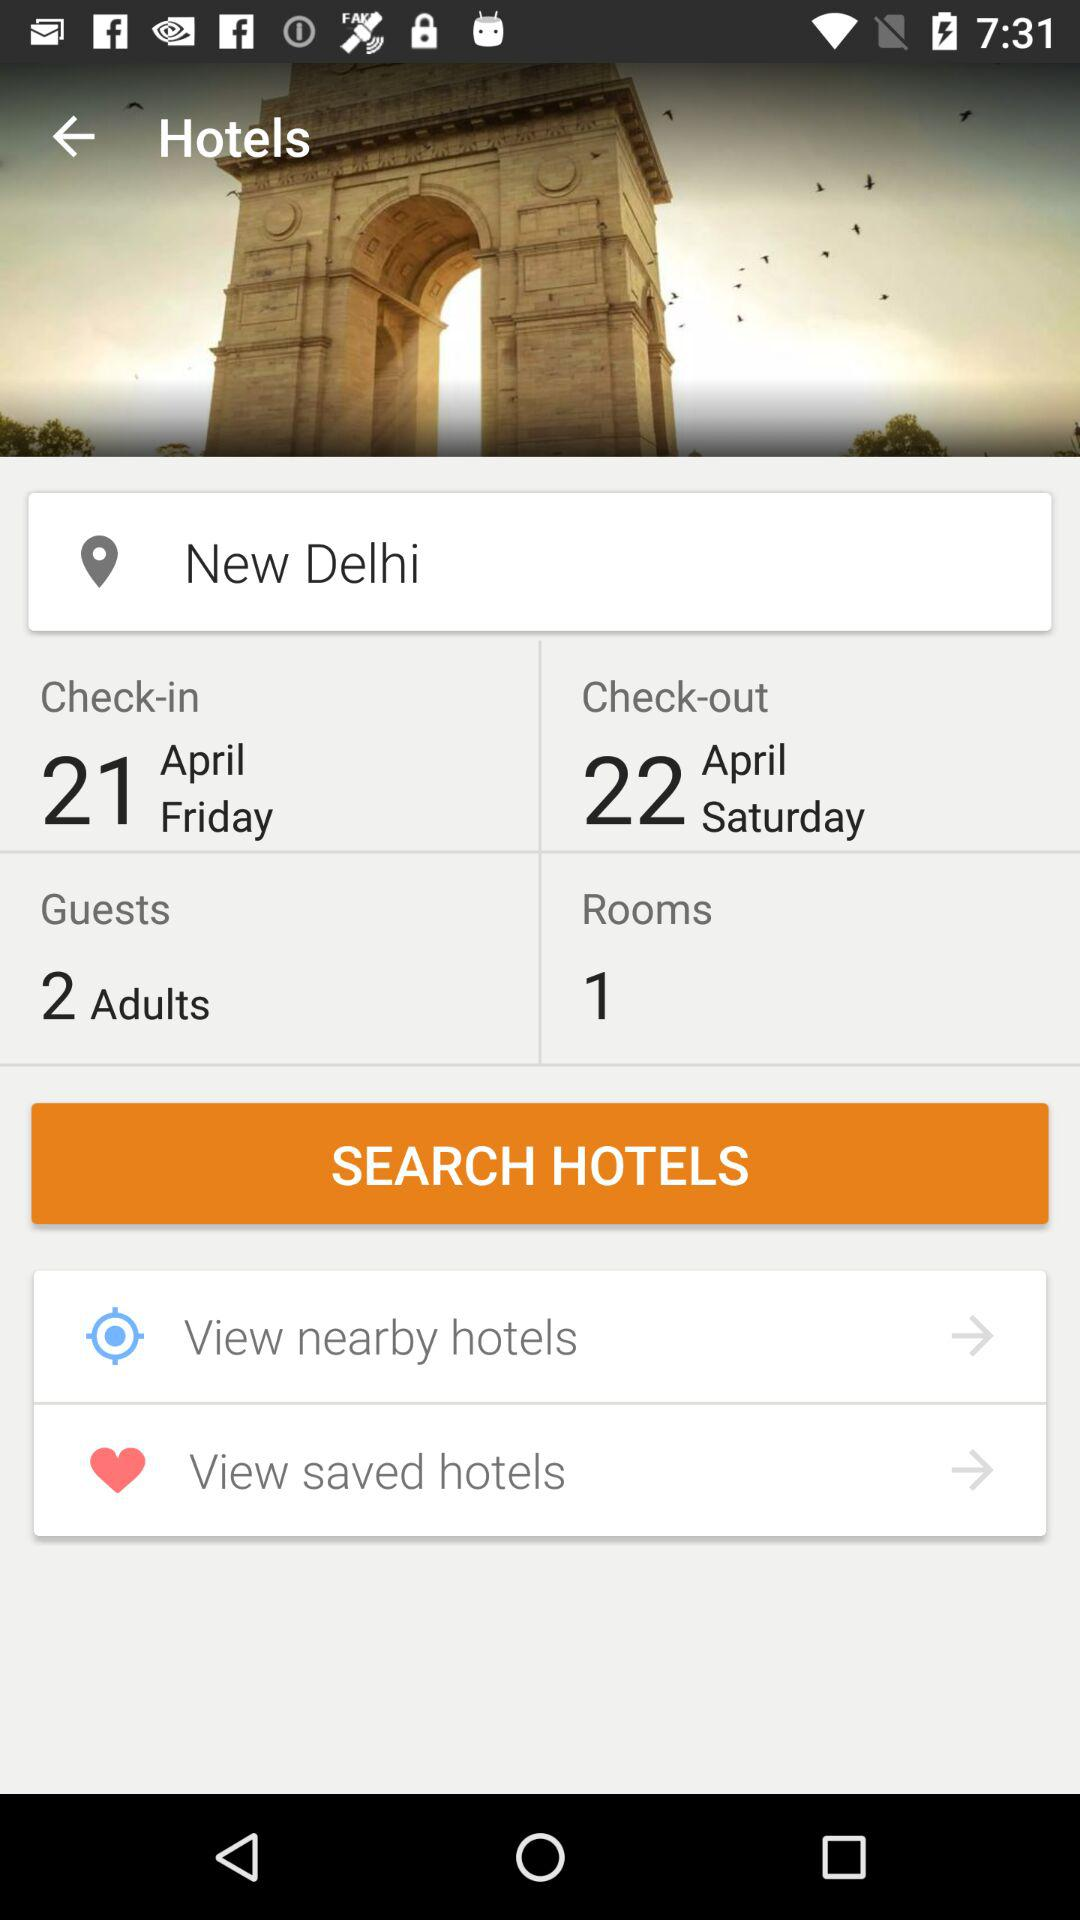How many rooms are selected? The selected room is 1. 